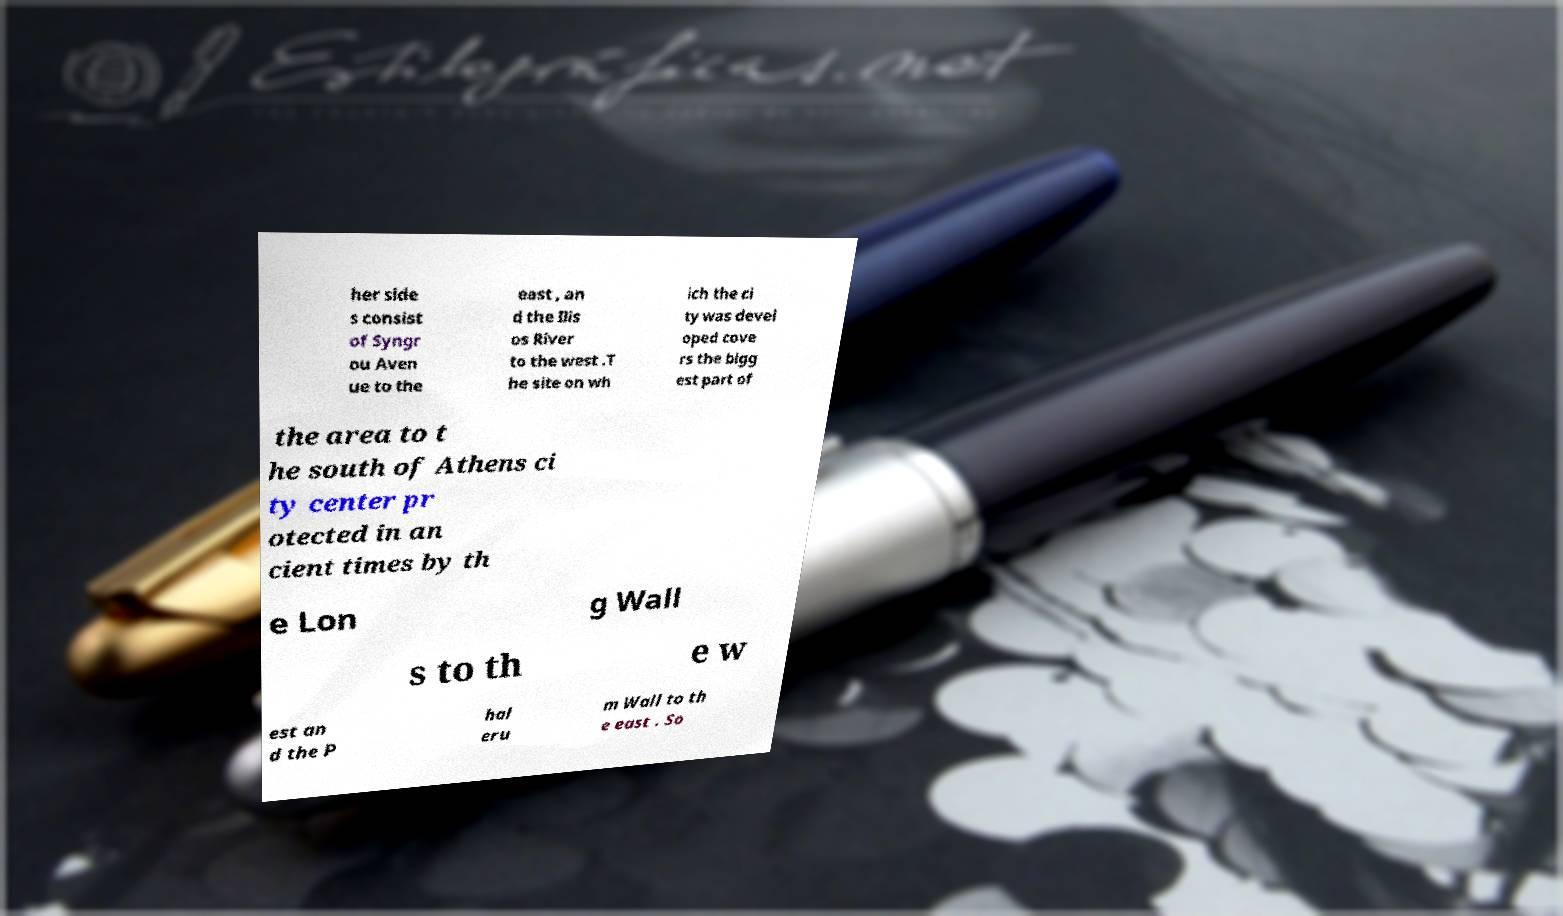Could you assist in decoding the text presented in this image and type it out clearly? her side s consist of Syngr ou Aven ue to the east , an d the Ilis os River to the west .T he site on wh ich the ci ty was devel oped cove rs the bigg est part of the area to t he south of Athens ci ty center pr otected in an cient times by th e Lon g Wall s to th e w est an d the P hal eru m Wall to th e east . So 